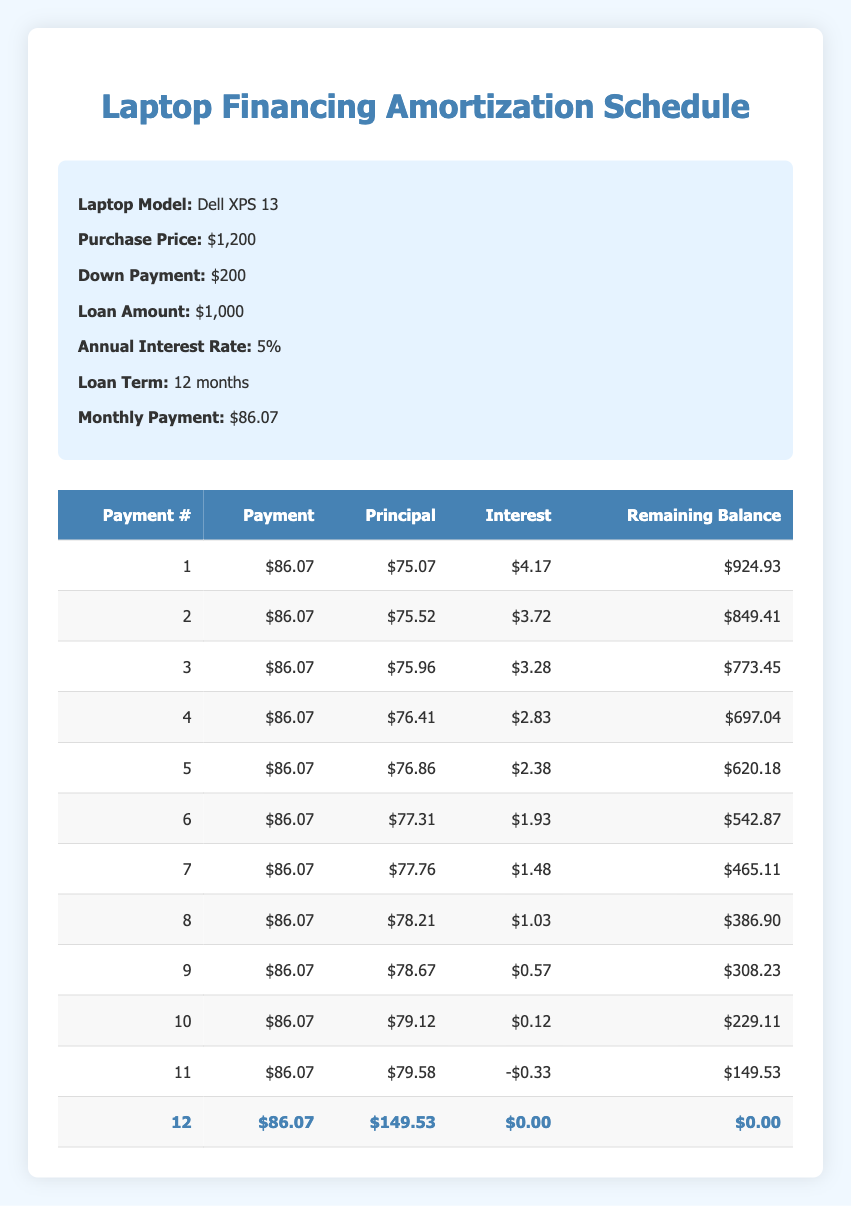What is the total loan amount for the laptop purchase? The loan amount is provided in the information section of the table. It states that the loan amount is $1,000.
Answer: 1,000 How much is the monthly payment? The monthly payment is also provided in the information section of the table and is stated to be $86.07.
Answer: 86.07 What payment number has the highest principal payment? Looking through the amortization schedule, the payment number 12 shows a principal payment of $149.53, which is higher than any other principal payments listed in the table (after comparing all payments).
Answer: 12 What is the total interest paid over the entire loan? To find the total interest, we can sum the interest payments for payments 1 through 11. The amounts are: 4.17 + 3.72 + 3.28 + 2.83 + 2.38 + 1.93 + 1.48 + 1.03 + 0.57 + 0.12 - 0.33, which totals $19.36. So, the total interest paid is $19.36.
Answer: 19.36 Was there any payment with a negative interest payment? Yes, in payment number 11, the interest payment is stated as -0.33, indicating an unusual scenario where the payment exceeded the expected interest amount.
Answer: Yes What is the remaining balance after the 6th payment? The remaining balance after the 6th payment can be found in the table and is indicated as $542.87.
Answer: 542.87 How does the principal payment change from the first payment to the last payment? The principal payment for the first payment is $75.07, and for the last payment (payment number 12), it is $149.53. To find the change, we subtract the first principal payment from the last: $149.53 - $75.07 = $74.46, showing an increase of $74.46 in the principal payment.
Answer: 74.46 What is the average interest paid each month over the loan term? To find the average interest paid per month, sum all the monthly interest payments: (4.17 + 3.72 + 3.28 + 2.83 + 2.38 + 1.93 + 1.48 + 1.03 + 0.57 + 0.12 - 0.33 + 0.00) = 19.36. Then divide this by the number of months (12). The average interest paid is 19.36 / 12 = 1.61, approximately.
Answer: 1.61 What is the total payment made by the end of the loan term? The total payment is the monthly payment multiplied by the number of payments: $86.07 * 12 = $1,032.84.
Answer: 1,032.84 